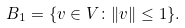Convert formula to latex. <formula><loc_0><loc_0><loc_500><loc_500>B _ { 1 } = \{ v \in V \colon \| v \| \leq 1 \} .</formula> 